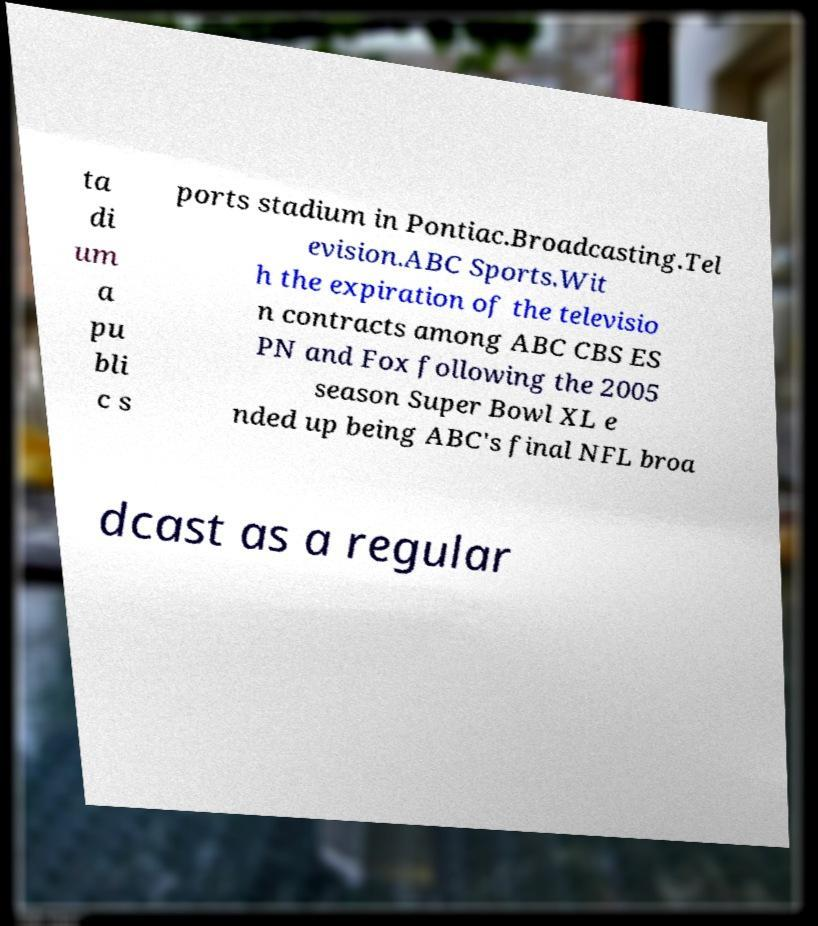Can you accurately transcribe the text from the provided image for me? ta di um a pu bli c s ports stadium in Pontiac.Broadcasting.Tel evision.ABC Sports.Wit h the expiration of the televisio n contracts among ABC CBS ES PN and Fox following the 2005 season Super Bowl XL e nded up being ABC's final NFL broa dcast as a regular 